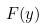<formula> <loc_0><loc_0><loc_500><loc_500>F ( y )</formula> 